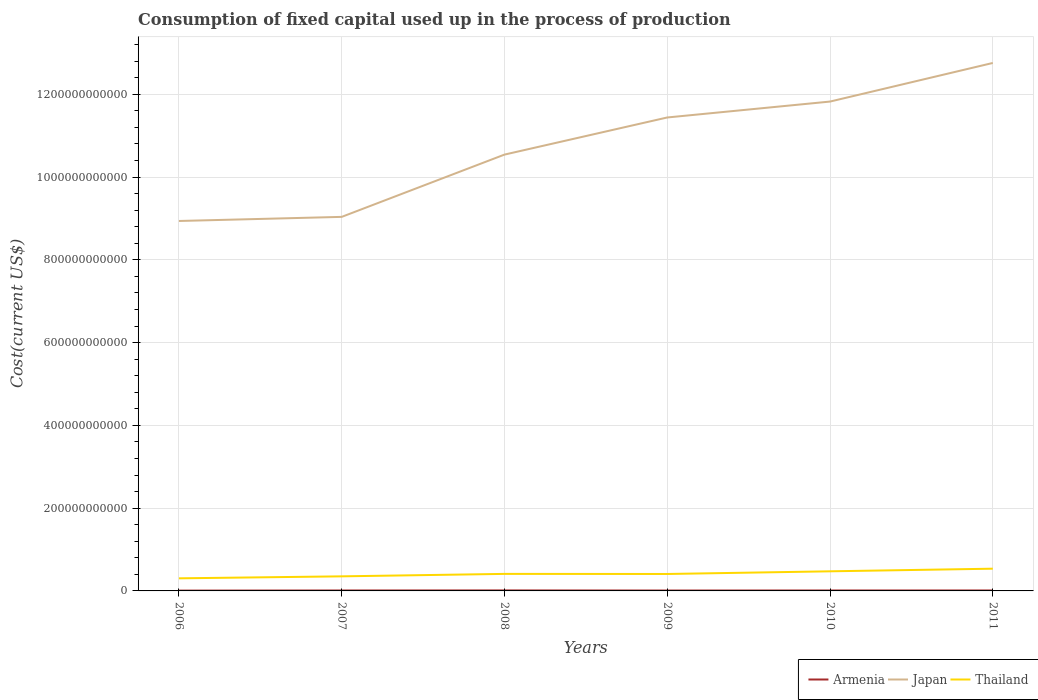Does the line corresponding to Armenia intersect with the line corresponding to Japan?
Provide a succinct answer. No. Is the number of lines equal to the number of legend labels?
Give a very brief answer. Yes. Across all years, what is the maximum amount consumed in the process of production in Armenia?
Offer a very short reply. 7.46e+08. What is the total amount consumed in the process of production in Japan in the graph?
Keep it short and to the point. -9.90e+09. What is the difference between the highest and the second highest amount consumed in the process of production in Thailand?
Make the answer very short. 2.33e+1. Is the amount consumed in the process of production in Japan strictly greater than the amount consumed in the process of production in Thailand over the years?
Give a very brief answer. No. How many lines are there?
Make the answer very short. 3. What is the difference between two consecutive major ticks on the Y-axis?
Your answer should be compact. 2.00e+11. Does the graph contain any zero values?
Make the answer very short. No. Does the graph contain grids?
Provide a short and direct response. Yes. Where does the legend appear in the graph?
Your answer should be compact. Bottom right. How many legend labels are there?
Your answer should be compact. 3. What is the title of the graph?
Your response must be concise. Consumption of fixed capital used up in the process of production. Does "Kazakhstan" appear as one of the legend labels in the graph?
Keep it short and to the point. No. What is the label or title of the X-axis?
Provide a succinct answer. Years. What is the label or title of the Y-axis?
Ensure brevity in your answer.  Cost(current US$). What is the Cost(current US$) of Armenia in 2006?
Make the answer very short. 7.46e+08. What is the Cost(current US$) in Japan in 2006?
Provide a short and direct response. 8.94e+11. What is the Cost(current US$) of Thailand in 2006?
Offer a very short reply. 3.04e+1. What is the Cost(current US$) in Armenia in 2007?
Your answer should be compact. 1.06e+09. What is the Cost(current US$) of Japan in 2007?
Provide a short and direct response. 9.04e+11. What is the Cost(current US$) in Thailand in 2007?
Keep it short and to the point. 3.52e+1. What is the Cost(current US$) of Armenia in 2008?
Your response must be concise. 1.23e+09. What is the Cost(current US$) of Japan in 2008?
Provide a short and direct response. 1.05e+12. What is the Cost(current US$) in Thailand in 2008?
Provide a short and direct response. 4.12e+1. What is the Cost(current US$) of Armenia in 2009?
Your response must be concise. 9.39e+08. What is the Cost(current US$) of Japan in 2009?
Offer a terse response. 1.14e+12. What is the Cost(current US$) in Thailand in 2009?
Provide a short and direct response. 4.09e+1. What is the Cost(current US$) of Armenia in 2010?
Provide a short and direct response. 1.04e+09. What is the Cost(current US$) of Japan in 2010?
Keep it short and to the point. 1.18e+12. What is the Cost(current US$) in Thailand in 2010?
Your answer should be compact. 4.74e+1. What is the Cost(current US$) in Armenia in 2011?
Your answer should be compact. 1.08e+09. What is the Cost(current US$) in Japan in 2011?
Provide a succinct answer. 1.28e+12. What is the Cost(current US$) of Thailand in 2011?
Offer a terse response. 5.37e+1. Across all years, what is the maximum Cost(current US$) of Armenia?
Keep it short and to the point. 1.23e+09. Across all years, what is the maximum Cost(current US$) in Japan?
Your answer should be very brief. 1.28e+12. Across all years, what is the maximum Cost(current US$) in Thailand?
Provide a short and direct response. 5.37e+1. Across all years, what is the minimum Cost(current US$) in Armenia?
Provide a succinct answer. 7.46e+08. Across all years, what is the minimum Cost(current US$) of Japan?
Keep it short and to the point. 8.94e+11. Across all years, what is the minimum Cost(current US$) of Thailand?
Provide a short and direct response. 3.04e+1. What is the total Cost(current US$) of Armenia in the graph?
Ensure brevity in your answer.  6.10e+09. What is the total Cost(current US$) of Japan in the graph?
Your answer should be compact. 6.45e+12. What is the total Cost(current US$) of Thailand in the graph?
Provide a succinct answer. 2.49e+11. What is the difference between the Cost(current US$) of Armenia in 2006 and that in 2007?
Ensure brevity in your answer.  -3.12e+08. What is the difference between the Cost(current US$) in Japan in 2006 and that in 2007?
Offer a terse response. -9.90e+09. What is the difference between the Cost(current US$) in Thailand in 2006 and that in 2007?
Keep it short and to the point. -4.77e+09. What is the difference between the Cost(current US$) of Armenia in 2006 and that in 2008?
Your response must be concise. -4.79e+08. What is the difference between the Cost(current US$) in Japan in 2006 and that in 2008?
Make the answer very short. -1.60e+11. What is the difference between the Cost(current US$) of Thailand in 2006 and that in 2008?
Ensure brevity in your answer.  -1.07e+1. What is the difference between the Cost(current US$) in Armenia in 2006 and that in 2009?
Provide a short and direct response. -1.93e+08. What is the difference between the Cost(current US$) in Japan in 2006 and that in 2009?
Offer a terse response. -2.50e+11. What is the difference between the Cost(current US$) of Thailand in 2006 and that in 2009?
Provide a short and direct response. -1.05e+1. What is the difference between the Cost(current US$) of Armenia in 2006 and that in 2010?
Your response must be concise. -2.97e+08. What is the difference between the Cost(current US$) of Japan in 2006 and that in 2010?
Offer a terse response. -2.89e+11. What is the difference between the Cost(current US$) in Thailand in 2006 and that in 2010?
Your answer should be very brief. -1.70e+1. What is the difference between the Cost(current US$) in Armenia in 2006 and that in 2011?
Ensure brevity in your answer.  -3.38e+08. What is the difference between the Cost(current US$) in Japan in 2006 and that in 2011?
Give a very brief answer. -3.82e+11. What is the difference between the Cost(current US$) in Thailand in 2006 and that in 2011?
Provide a short and direct response. -2.33e+1. What is the difference between the Cost(current US$) of Armenia in 2007 and that in 2008?
Offer a very short reply. -1.67e+08. What is the difference between the Cost(current US$) of Japan in 2007 and that in 2008?
Provide a succinct answer. -1.50e+11. What is the difference between the Cost(current US$) in Thailand in 2007 and that in 2008?
Offer a very short reply. -5.95e+09. What is the difference between the Cost(current US$) of Armenia in 2007 and that in 2009?
Your answer should be compact. 1.19e+08. What is the difference between the Cost(current US$) in Japan in 2007 and that in 2009?
Ensure brevity in your answer.  -2.40e+11. What is the difference between the Cost(current US$) in Thailand in 2007 and that in 2009?
Your answer should be compact. -5.73e+09. What is the difference between the Cost(current US$) of Armenia in 2007 and that in 2010?
Offer a terse response. 1.42e+07. What is the difference between the Cost(current US$) in Japan in 2007 and that in 2010?
Offer a terse response. -2.79e+11. What is the difference between the Cost(current US$) in Thailand in 2007 and that in 2010?
Keep it short and to the point. -1.22e+1. What is the difference between the Cost(current US$) in Armenia in 2007 and that in 2011?
Make the answer very short. -2.60e+07. What is the difference between the Cost(current US$) in Japan in 2007 and that in 2011?
Provide a short and direct response. -3.72e+11. What is the difference between the Cost(current US$) of Thailand in 2007 and that in 2011?
Your response must be concise. -1.85e+1. What is the difference between the Cost(current US$) of Armenia in 2008 and that in 2009?
Make the answer very short. 2.86e+08. What is the difference between the Cost(current US$) of Japan in 2008 and that in 2009?
Make the answer very short. -8.97e+1. What is the difference between the Cost(current US$) in Thailand in 2008 and that in 2009?
Offer a terse response. 2.24e+08. What is the difference between the Cost(current US$) in Armenia in 2008 and that in 2010?
Give a very brief answer. 1.81e+08. What is the difference between the Cost(current US$) in Japan in 2008 and that in 2010?
Your response must be concise. -1.28e+11. What is the difference between the Cost(current US$) of Thailand in 2008 and that in 2010?
Your response must be concise. -6.23e+09. What is the difference between the Cost(current US$) in Armenia in 2008 and that in 2011?
Provide a succinct answer. 1.41e+08. What is the difference between the Cost(current US$) of Japan in 2008 and that in 2011?
Give a very brief answer. -2.21e+11. What is the difference between the Cost(current US$) of Thailand in 2008 and that in 2011?
Your answer should be very brief. -1.25e+1. What is the difference between the Cost(current US$) of Armenia in 2009 and that in 2010?
Provide a short and direct response. -1.05e+08. What is the difference between the Cost(current US$) of Japan in 2009 and that in 2010?
Provide a short and direct response. -3.84e+1. What is the difference between the Cost(current US$) of Thailand in 2009 and that in 2010?
Your answer should be very brief. -6.46e+09. What is the difference between the Cost(current US$) in Armenia in 2009 and that in 2011?
Offer a terse response. -1.45e+08. What is the difference between the Cost(current US$) of Japan in 2009 and that in 2011?
Offer a terse response. -1.32e+11. What is the difference between the Cost(current US$) in Thailand in 2009 and that in 2011?
Keep it short and to the point. -1.28e+1. What is the difference between the Cost(current US$) in Armenia in 2010 and that in 2011?
Your answer should be compact. -4.02e+07. What is the difference between the Cost(current US$) in Japan in 2010 and that in 2011?
Offer a terse response. -9.33e+1. What is the difference between the Cost(current US$) of Thailand in 2010 and that in 2011?
Offer a terse response. -6.31e+09. What is the difference between the Cost(current US$) of Armenia in 2006 and the Cost(current US$) of Japan in 2007?
Provide a succinct answer. -9.03e+11. What is the difference between the Cost(current US$) in Armenia in 2006 and the Cost(current US$) in Thailand in 2007?
Ensure brevity in your answer.  -3.45e+1. What is the difference between the Cost(current US$) in Japan in 2006 and the Cost(current US$) in Thailand in 2007?
Your response must be concise. 8.59e+11. What is the difference between the Cost(current US$) in Armenia in 2006 and the Cost(current US$) in Japan in 2008?
Your answer should be very brief. -1.05e+12. What is the difference between the Cost(current US$) of Armenia in 2006 and the Cost(current US$) of Thailand in 2008?
Provide a succinct answer. -4.04e+1. What is the difference between the Cost(current US$) of Japan in 2006 and the Cost(current US$) of Thailand in 2008?
Your response must be concise. 8.53e+11. What is the difference between the Cost(current US$) in Armenia in 2006 and the Cost(current US$) in Japan in 2009?
Give a very brief answer. -1.14e+12. What is the difference between the Cost(current US$) in Armenia in 2006 and the Cost(current US$) in Thailand in 2009?
Ensure brevity in your answer.  -4.02e+1. What is the difference between the Cost(current US$) in Japan in 2006 and the Cost(current US$) in Thailand in 2009?
Provide a short and direct response. 8.53e+11. What is the difference between the Cost(current US$) of Armenia in 2006 and the Cost(current US$) of Japan in 2010?
Make the answer very short. -1.18e+12. What is the difference between the Cost(current US$) of Armenia in 2006 and the Cost(current US$) of Thailand in 2010?
Your answer should be very brief. -4.66e+1. What is the difference between the Cost(current US$) in Japan in 2006 and the Cost(current US$) in Thailand in 2010?
Your answer should be compact. 8.46e+11. What is the difference between the Cost(current US$) in Armenia in 2006 and the Cost(current US$) in Japan in 2011?
Make the answer very short. -1.27e+12. What is the difference between the Cost(current US$) of Armenia in 2006 and the Cost(current US$) of Thailand in 2011?
Keep it short and to the point. -5.30e+1. What is the difference between the Cost(current US$) in Japan in 2006 and the Cost(current US$) in Thailand in 2011?
Ensure brevity in your answer.  8.40e+11. What is the difference between the Cost(current US$) in Armenia in 2007 and the Cost(current US$) in Japan in 2008?
Make the answer very short. -1.05e+12. What is the difference between the Cost(current US$) of Armenia in 2007 and the Cost(current US$) of Thailand in 2008?
Give a very brief answer. -4.01e+1. What is the difference between the Cost(current US$) in Japan in 2007 and the Cost(current US$) in Thailand in 2008?
Make the answer very short. 8.63e+11. What is the difference between the Cost(current US$) of Armenia in 2007 and the Cost(current US$) of Japan in 2009?
Make the answer very short. -1.14e+12. What is the difference between the Cost(current US$) in Armenia in 2007 and the Cost(current US$) in Thailand in 2009?
Your answer should be very brief. -3.99e+1. What is the difference between the Cost(current US$) of Japan in 2007 and the Cost(current US$) of Thailand in 2009?
Offer a terse response. 8.63e+11. What is the difference between the Cost(current US$) in Armenia in 2007 and the Cost(current US$) in Japan in 2010?
Give a very brief answer. -1.18e+12. What is the difference between the Cost(current US$) in Armenia in 2007 and the Cost(current US$) in Thailand in 2010?
Ensure brevity in your answer.  -4.63e+1. What is the difference between the Cost(current US$) in Japan in 2007 and the Cost(current US$) in Thailand in 2010?
Offer a terse response. 8.56e+11. What is the difference between the Cost(current US$) in Armenia in 2007 and the Cost(current US$) in Japan in 2011?
Ensure brevity in your answer.  -1.27e+12. What is the difference between the Cost(current US$) of Armenia in 2007 and the Cost(current US$) of Thailand in 2011?
Offer a very short reply. -5.26e+1. What is the difference between the Cost(current US$) in Japan in 2007 and the Cost(current US$) in Thailand in 2011?
Your response must be concise. 8.50e+11. What is the difference between the Cost(current US$) in Armenia in 2008 and the Cost(current US$) in Japan in 2009?
Make the answer very short. -1.14e+12. What is the difference between the Cost(current US$) of Armenia in 2008 and the Cost(current US$) of Thailand in 2009?
Ensure brevity in your answer.  -3.97e+1. What is the difference between the Cost(current US$) in Japan in 2008 and the Cost(current US$) in Thailand in 2009?
Your response must be concise. 1.01e+12. What is the difference between the Cost(current US$) of Armenia in 2008 and the Cost(current US$) of Japan in 2010?
Make the answer very short. -1.18e+12. What is the difference between the Cost(current US$) in Armenia in 2008 and the Cost(current US$) in Thailand in 2010?
Ensure brevity in your answer.  -4.62e+1. What is the difference between the Cost(current US$) in Japan in 2008 and the Cost(current US$) in Thailand in 2010?
Your response must be concise. 1.01e+12. What is the difference between the Cost(current US$) of Armenia in 2008 and the Cost(current US$) of Japan in 2011?
Keep it short and to the point. -1.27e+12. What is the difference between the Cost(current US$) of Armenia in 2008 and the Cost(current US$) of Thailand in 2011?
Your response must be concise. -5.25e+1. What is the difference between the Cost(current US$) of Japan in 2008 and the Cost(current US$) of Thailand in 2011?
Your response must be concise. 1.00e+12. What is the difference between the Cost(current US$) of Armenia in 2009 and the Cost(current US$) of Japan in 2010?
Ensure brevity in your answer.  -1.18e+12. What is the difference between the Cost(current US$) of Armenia in 2009 and the Cost(current US$) of Thailand in 2010?
Keep it short and to the point. -4.64e+1. What is the difference between the Cost(current US$) of Japan in 2009 and the Cost(current US$) of Thailand in 2010?
Provide a short and direct response. 1.10e+12. What is the difference between the Cost(current US$) of Armenia in 2009 and the Cost(current US$) of Japan in 2011?
Your answer should be very brief. -1.27e+12. What is the difference between the Cost(current US$) of Armenia in 2009 and the Cost(current US$) of Thailand in 2011?
Provide a short and direct response. -5.28e+1. What is the difference between the Cost(current US$) of Japan in 2009 and the Cost(current US$) of Thailand in 2011?
Offer a very short reply. 1.09e+12. What is the difference between the Cost(current US$) of Armenia in 2010 and the Cost(current US$) of Japan in 2011?
Offer a terse response. -1.27e+12. What is the difference between the Cost(current US$) of Armenia in 2010 and the Cost(current US$) of Thailand in 2011?
Ensure brevity in your answer.  -5.27e+1. What is the difference between the Cost(current US$) in Japan in 2010 and the Cost(current US$) in Thailand in 2011?
Give a very brief answer. 1.13e+12. What is the average Cost(current US$) in Armenia per year?
Your response must be concise. 1.02e+09. What is the average Cost(current US$) of Japan per year?
Your response must be concise. 1.08e+12. What is the average Cost(current US$) of Thailand per year?
Your answer should be compact. 4.15e+1. In the year 2006, what is the difference between the Cost(current US$) in Armenia and Cost(current US$) in Japan?
Your response must be concise. -8.93e+11. In the year 2006, what is the difference between the Cost(current US$) of Armenia and Cost(current US$) of Thailand?
Your answer should be very brief. -2.97e+1. In the year 2006, what is the difference between the Cost(current US$) of Japan and Cost(current US$) of Thailand?
Provide a succinct answer. 8.63e+11. In the year 2007, what is the difference between the Cost(current US$) of Armenia and Cost(current US$) of Japan?
Provide a succinct answer. -9.03e+11. In the year 2007, what is the difference between the Cost(current US$) in Armenia and Cost(current US$) in Thailand?
Ensure brevity in your answer.  -3.41e+1. In the year 2007, what is the difference between the Cost(current US$) in Japan and Cost(current US$) in Thailand?
Keep it short and to the point. 8.68e+11. In the year 2008, what is the difference between the Cost(current US$) in Armenia and Cost(current US$) in Japan?
Make the answer very short. -1.05e+12. In the year 2008, what is the difference between the Cost(current US$) in Armenia and Cost(current US$) in Thailand?
Give a very brief answer. -3.99e+1. In the year 2008, what is the difference between the Cost(current US$) of Japan and Cost(current US$) of Thailand?
Provide a succinct answer. 1.01e+12. In the year 2009, what is the difference between the Cost(current US$) in Armenia and Cost(current US$) in Japan?
Ensure brevity in your answer.  -1.14e+12. In the year 2009, what is the difference between the Cost(current US$) of Armenia and Cost(current US$) of Thailand?
Provide a short and direct response. -4.00e+1. In the year 2009, what is the difference between the Cost(current US$) in Japan and Cost(current US$) in Thailand?
Your answer should be very brief. 1.10e+12. In the year 2010, what is the difference between the Cost(current US$) in Armenia and Cost(current US$) in Japan?
Keep it short and to the point. -1.18e+12. In the year 2010, what is the difference between the Cost(current US$) of Armenia and Cost(current US$) of Thailand?
Keep it short and to the point. -4.63e+1. In the year 2010, what is the difference between the Cost(current US$) in Japan and Cost(current US$) in Thailand?
Offer a terse response. 1.13e+12. In the year 2011, what is the difference between the Cost(current US$) in Armenia and Cost(current US$) in Japan?
Your answer should be very brief. -1.27e+12. In the year 2011, what is the difference between the Cost(current US$) in Armenia and Cost(current US$) in Thailand?
Your response must be concise. -5.26e+1. In the year 2011, what is the difference between the Cost(current US$) of Japan and Cost(current US$) of Thailand?
Keep it short and to the point. 1.22e+12. What is the ratio of the Cost(current US$) in Armenia in 2006 to that in 2007?
Offer a very short reply. 0.71. What is the ratio of the Cost(current US$) of Thailand in 2006 to that in 2007?
Keep it short and to the point. 0.86. What is the ratio of the Cost(current US$) of Armenia in 2006 to that in 2008?
Your answer should be compact. 0.61. What is the ratio of the Cost(current US$) of Japan in 2006 to that in 2008?
Your answer should be compact. 0.85. What is the ratio of the Cost(current US$) of Thailand in 2006 to that in 2008?
Your answer should be compact. 0.74. What is the ratio of the Cost(current US$) in Armenia in 2006 to that in 2009?
Keep it short and to the point. 0.79. What is the ratio of the Cost(current US$) of Japan in 2006 to that in 2009?
Provide a succinct answer. 0.78. What is the ratio of the Cost(current US$) of Thailand in 2006 to that in 2009?
Your response must be concise. 0.74. What is the ratio of the Cost(current US$) in Armenia in 2006 to that in 2010?
Make the answer very short. 0.72. What is the ratio of the Cost(current US$) in Japan in 2006 to that in 2010?
Provide a succinct answer. 0.76. What is the ratio of the Cost(current US$) in Thailand in 2006 to that in 2010?
Give a very brief answer. 0.64. What is the ratio of the Cost(current US$) of Armenia in 2006 to that in 2011?
Give a very brief answer. 0.69. What is the ratio of the Cost(current US$) in Japan in 2006 to that in 2011?
Offer a terse response. 0.7. What is the ratio of the Cost(current US$) of Thailand in 2006 to that in 2011?
Make the answer very short. 0.57. What is the ratio of the Cost(current US$) in Armenia in 2007 to that in 2008?
Provide a short and direct response. 0.86. What is the ratio of the Cost(current US$) in Japan in 2007 to that in 2008?
Provide a succinct answer. 0.86. What is the ratio of the Cost(current US$) in Thailand in 2007 to that in 2008?
Provide a succinct answer. 0.86. What is the ratio of the Cost(current US$) in Armenia in 2007 to that in 2009?
Provide a short and direct response. 1.13. What is the ratio of the Cost(current US$) of Japan in 2007 to that in 2009?
Your response must be concise. 0.79. What is the ratio of the Cost(current US$) of Thailand in 2007 to that in 2009?
Your answer should be very brief. 0.86. What is the ratio of the Cost(current US$) of Armenia in 2007 to that in 2010?
Offer a terse response. 1.01. What is the ratio of the Cost(current US$) in Japan in 2007 to that in 2010?
Ensure brevity in your answer.  0.76. What is the ratio of the Cost(current US$) in Thailand in 2007 to that in 2010?
Provide a short and direct response. 0.74. What is the ratio of the Cost(current US$) in Japan in 2007 to that in 2011?
Your answer should be very brief. 0.71. What is the ratio of the Cost(current US$) in Thailand in 2007 to that in 2011?
Make the answer very short. 0.66. What is the ratio of the Cost(current US$) in Armenia in 2008 to that in 2009?
Provide a succinct answer. 1.3. What is the ratio of the Cost(current US$) in Japan in 2008 to that in 2009?
Your response must be concise. 0.92. What is the ratio of the Cost(current US$) of Armenia in 2008 to that in 2010?
Give a very brief answer. 1.17. What is the ratio of the Cost(current US$) of Japan in 2008 to that in 2010?
Make the answer very short. 0.89. What is the ratio of the Cost(current US$) of Thailand in 2008 to that in 2010?
Your answer should be compact. 0.87. What is the ratio of the Cost(current US$) in Armenia in 2008 to that in 2011?
Your response must be concise. 1.13. What is the ratio of the Cost(current US$) in Japan in 2008 to that in 2011?
Provide a short and direct response. 0.83. What is the ratio of the Cost(current US$) in Thailand in 2008 to that in 2011?
Offer a very short reply. 0.77. What is the ratio of the Cost(current US$) in Armenia in 2009 to that in 2010?
Your answer should be very brief. 0.9. What is the ratio of the Cost(current US$) in Japan in 2009 to that in 2010?
Ensure brevity in your answer.  0.97. What is the ratio of the Cost(current US$) of Thailand in 2009 to that in 2010?
Your response must be concise. 0.86. What is the ratio of the Cost(current US$) in Armenia in 2009 to that in 2011?
Give a very brief answer. 0.87. What is the ratio of the Cost(current US$) of Japan in 2009 to that in 2011?
Offer a terse response. 0.9. What is the ratio of the Cost(current US$) in Thailand in 2009 to that in 2011?
Your answer should be compact. 0.76. What is the ratio of the Cost(current US$) of Armenia in 2010 to that in 2011?
Your answer should be compact. 0.96. What is the ratio of the Cost(current US$) in Japan in 2010 to that in 2011?
Give a very brief answer. 0.93. What is the ratio of the Cost(current US$) in Thailand in 2010 to that in 2011?
Your answer should be compact. 0.88. What is the difference between the highest and the second highest Cost(current US$) of Armenia?
Your response must be concise. 1.41e+08. What is the difference between the highest and the second highest Cost(current US$) in Japan?
Provide a succinct answer. 9.33e+1. What is the difference between the highest and the second highest Cost(current US$) of Thailand?
Provide a short and direct response. 6.31e+09. What is the difference between the highest and the lowest Cost(current US$) in Armenia?
Give a very brief answer. 4.79e+08. What is the difference between the highest and the lowest Cost(current US$) of Japan?
Offer a very short reply. 3.82e+11. What is the difference between the highest and the lowest Cost(current US$) of Thailand?
Offer a very short reply. 2.33e+1. 